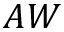<formula> <loc_0><loc_0><loc_500><loc_500>A W</formula> 